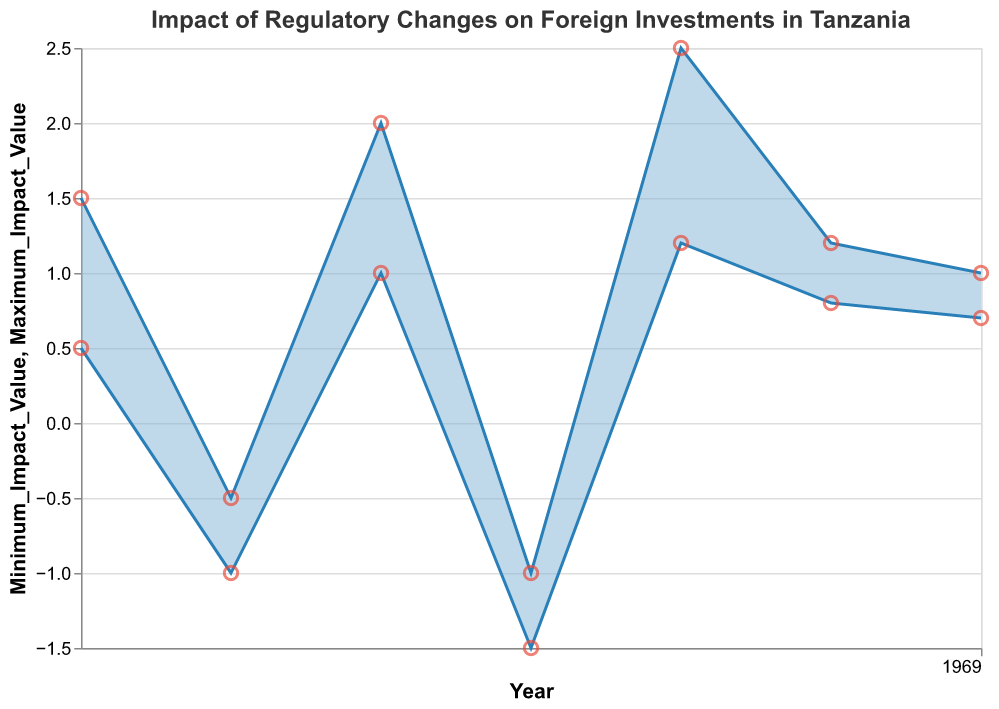What is the title of the figure? The title of the figure is typically displayed at the top. In this figure, the title indicates the focus of the chart.
Answer: "Impact of Regulatory Changes on Foreign Investments in Tanzania" How many regulation changes are illustrated in the figure? To find the number of regulation changes, count the distinct data points or intervals shown on the x-axis (for each year).
Answer: 7 In which year was the "Streamlined Business Licensing Processes" regulation change implemented? Look for the year associated with the "Streamlined Business Licensing Processes" data point in the tooltip or within the chart.
Answer: 2019 What is the range of the impact values for "Increased Local Content Requirements"? Identify the minimum and maximum impact values displayed in the tooltip for "Increased Local Content Requirements."
Answer: [-1.5, -1] Which year had the highest maximum impact value and what was the value? Compare the maximum impact values (the upper boundaries of the intervals) visually.
Answer: 2021, 2.5 What is the average maximum impact value of regulations introduced in 2017 and 2023? Add the maximum impact values for 2017 and 2023 together and divide by the number of values (2). The values are 1.5 and 1.0, so (1.5 + 1.0) / 2 = 1.25.
Answer: 1.25 Which regulation change had the lowest minimum impact value and what was the value? Identify the regulation with the lowest minimum value displayed in the chart or tooltip, which appears at the lowest point.
Answer: "Increased Local Content Requirements" (-1.5) Compare the impact range for the "Introduction of TIC One-Stop-Shop" with "Revised Tax Incentives Policies". Which one has a wider range? Subtract the minimum impact value from the maximum impact value for each regulation. (1.5 - 0.5) for TIC One-Stop-Shop = 1.0 and (1.2 - 0.8) = 0.4 for Revised Tax Incentives Policies.
Answer: "Introduction of TIC One-Stop-Shop" (1.0) Which regulation change had a positive impact on ease of doing business every year? Analyzing the minimum and maximum impact values, look for a regulation where both values are positive.
Answer: Multiple regulations, but "Streamlined Business Licensing Processes"  is notable with values (1, 2) What is the total range of impact values across all years? Find the lowest minimum value and the highest maximum value among all data points. The lowest minimum is -1.5 (2020), and the highest maximum is 2.5 (2021). The range is 2.5 - (-1.5) = 4.
Answer: 4 